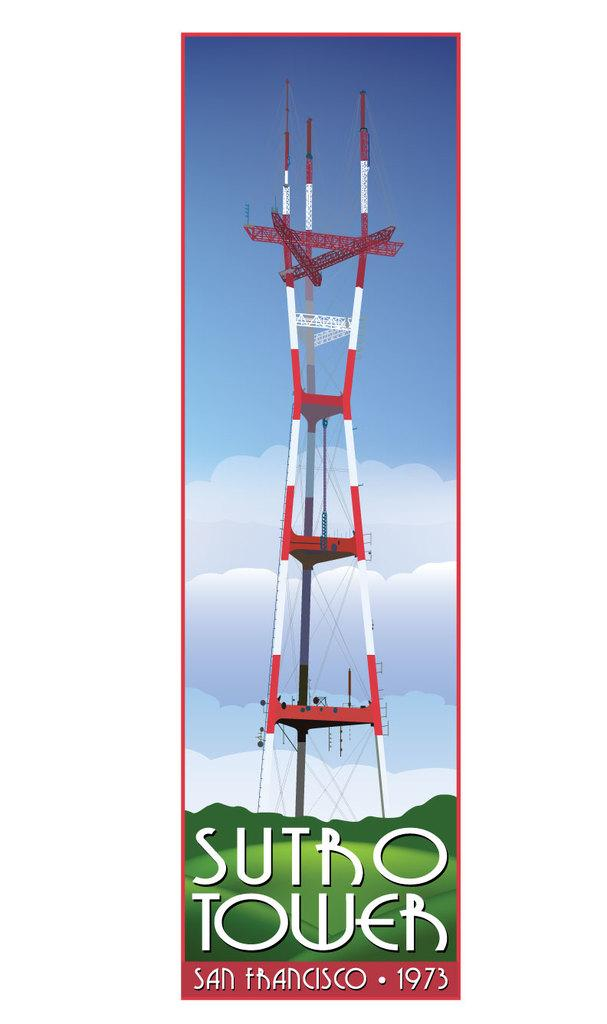<image>
Share a concise interpretation of the image provided. A cell phone tower titled Sutro Tower San Francisco 1973. 